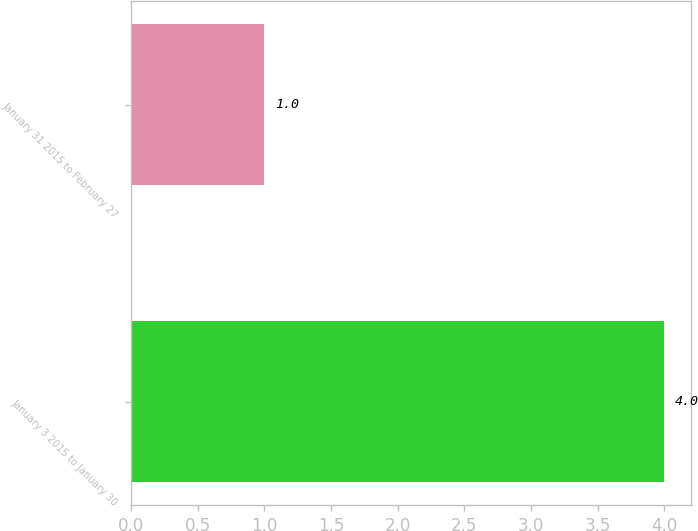Convert chart to OTSL. <chart><loc_0><loc_0><loc_500><loc_500><bar_chart><fcel>January 3 2015 to January 30<fcel>January 31 2015 to February 27<nl><fcel>4<fcel>1<nl></chart> 